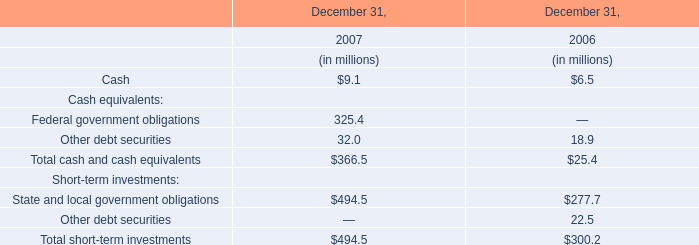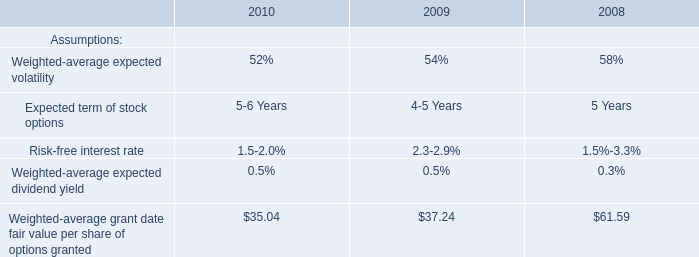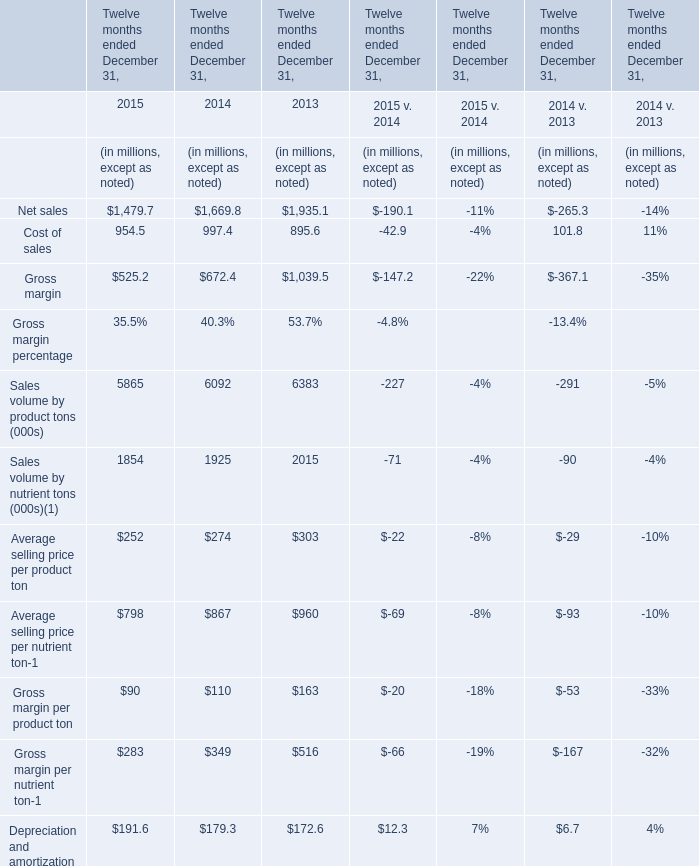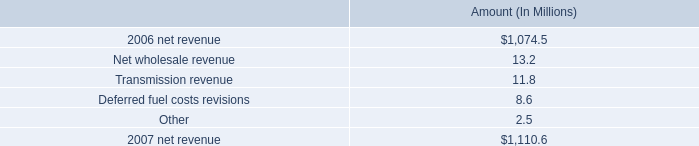what is the growth rate in net revenue in 2007 for entergy arkansas , inc.? 
Computations: ((1110.6 - 1074.5) / 1074.5)
Answer: 0.0336. 